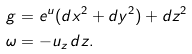<formula> <loc_0><loc_0><loc_500><loc_500>g & = e ^ { u } ( d x ^ { 2 } + d y ^ { 2 } ) + d z ^ { 2 } \\ \omega & = - u _ { z } \, d z .</formula> 